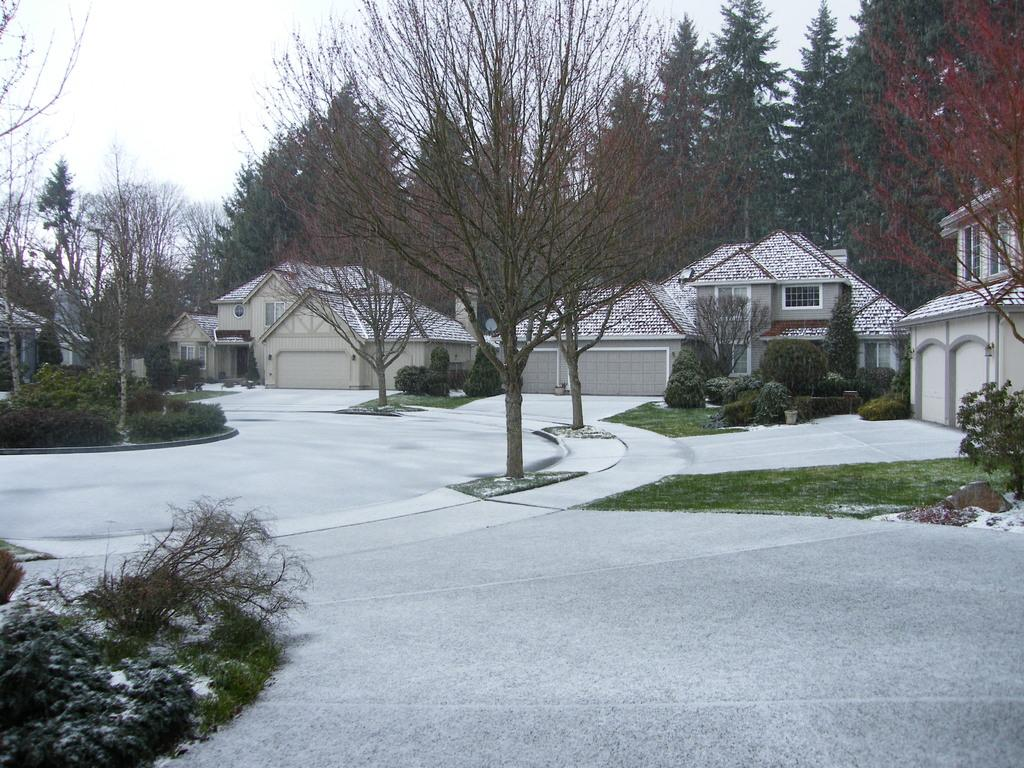What type of vegetation can be seen in the image? There are trees and plants in the image. What is on the pavement in the image? There is grass on the pavement. What can be seen in the distance in the image? There are houses and trees in the background of the image. What part of the natural environment is visible in the image? The sky is visible in the background of the image. Which actor is performing on the grass in the image? There is no actor performing on the grass in the image; it is a natural scene with trees, plants, and grass. 